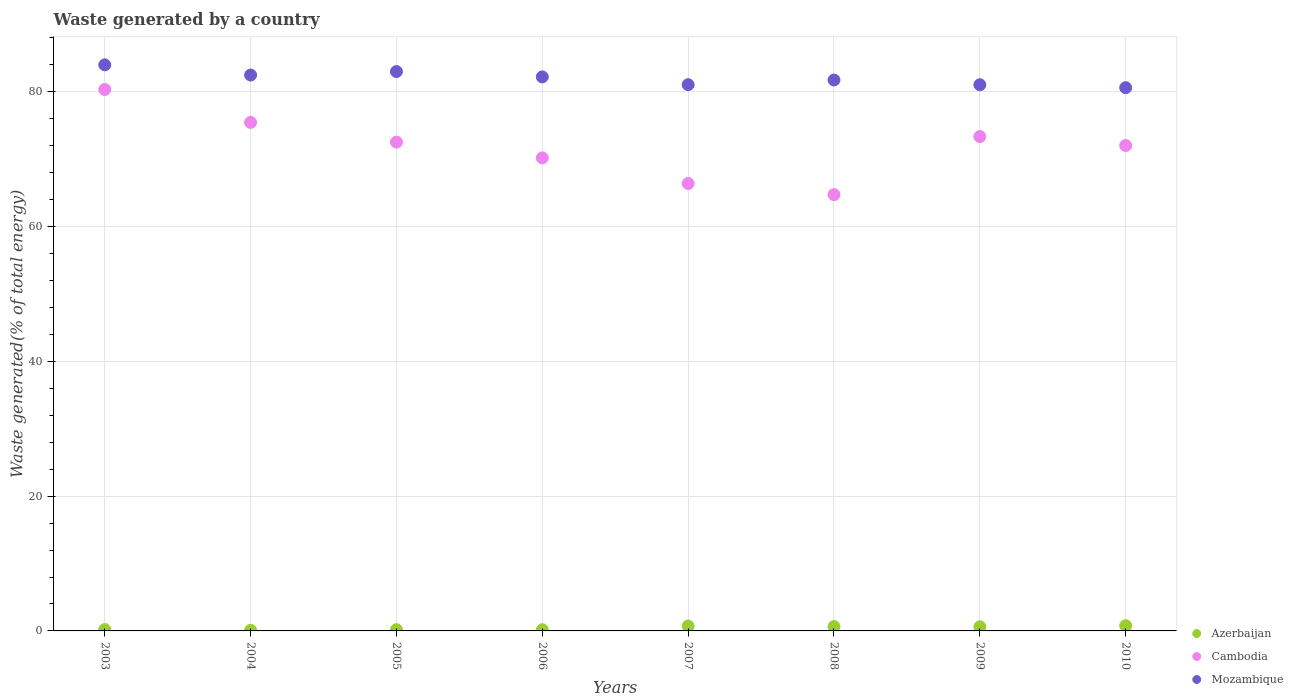How many different coloured dotlines are there?
Keep it short and to the point. 3. What is the total waste generated in Mozambique in 2006?
Your answer should be compact. 82.2. Across all years, what is the maximum total waste generated in Mozambique?
Your answer should be compact. 83.99. Across all years, what is the minimum total waste generated in Mozambique?
Give a very brief answer. 80.6. In which year was the total waste generated in Azerbaijan maximum?
Provide a succinct answer. 2010. In which year was the total waste generated in Mozambique minimum?
Provide a succinct answer. 2010. What is the total total waste generated in Mozambique in the graph?
Your response must be concise. 656.09. What is the difference between the total waste generated in Azerbaijan in 2004 and that in 2006?
Your response must be concise. -0.09. What is the difference between the total waste generated in Mozambique in 2010 and the total waste generated in Cambodia in 2008?
Offer a terse response. 15.87. What is the average total waste generated in Azerbaijan per year?
Offer a terse response. 0.43. In the year 2008, what is the difference between the total waste generated in Cambodia and total waste generated in Azerbaijan?
Ensure brevity in your answer.  64.09. What is the ratio of the total waste generated in Mozambique in 2003 to that in 2005?
Your answer should be very brief. 1.01. Is the total waste generated in Cambodia in 2005 less than that in 2006?
Give a very brief answer. No. What is the difference between the highest and the second highest total waste generated in Cambodia?
Your answer should be very brief. 4.89. What is the difference between the highest and the lowest total waste generated in Mozambique?
Offer a terse response. 3.39. Is it the case that in every year, the sum of the total waste generated in Mozambique and total waste generated in Cambodia  is greater than the total waste generated in Azerbaijan?
Your response must be concise. Yes. Is the total waste generated in Mozambique strictly greater than the total waste generated in Cambodia over the years?
Make the answer very short. Yes. Is the total waste generated in Cambodia strictly less than the total waste generated in Mozambique over the years?
Provide a short and direct response. Yes. How many dotlines are there?
Offer a terse response. 3. Are the values on the major ticks of Y-axis written in scientific E-notation?
Your response must be concise. No. Does the graph contain any zero values?
Your answer should be compact. No. How are the legend labels stacked?
Your answer should be compact. Vertical. What is the title of the graph?
Ensure brevity in your answer.  Waste generated by a country. Does "Canada" appear as one of the legend labels in the graph?
Give a very brief answer. No. What is the label or title of the X-axis?
Provide a short and direct response. Years. What is the label or title of the Y-axis?
Give a very brief answer. Waste generated(% of total energy). What is the Waste generated(% of total energy) in Azerbaijan in 2003?
Ensure brevity in your answer.  0.2. What is the Waste generated(% of total energy) in Cambodia in 2003?
Keep it short and to the point. 80.34. What is the Waste generated(% of total energy) in Mozambique in 2003?
Provide a succinct answer. 83.99. What is the Waste generated(% of total energy) of Azerbaijan in 2004?
Offer a terse response. 0.09. What is the Waste generated(% of total energy) of Cambodia in 2004?
Your answer should be compact. 75.45. What is the Waste generated(% of total energy) of Mozambique in 2004?
Keep it short and to the point. 82.48. What is the Waste generated(% of total energy) in Azerbaijan in 2005?
Provide a short and direct response. 0.19. What is the Waste generated(% of total energy) in Cambodia in 2005?
Offer a very short reply. 72.53. What is the Waste generated(% of total energy) of Mozambique in 2005?
Provide a short and direct response. 83. What is the Waste generated(% of total energy) of Azerbaijan in 2006?
Keep it short and to the point. 0.18. What is the Waste generated(% of total energy) in Cambodia in 2006?
Offer a very short reply. 70.19. What is the Waste generated(% of total energy) of Mozambique in 2006?
Your answer should be compact. 82.2. What is the Waste generated(% of total energy) in Azerbaijan in 2007?
Offer a very short reply. 0.73. What is the Waste generated(% of total energy) in Cambodia in 2007?
Provide a succinct answer. 66.38. What is the Waste generated(% of total energy) in Mozambique in 2007?
Make the answer very short. 81.05. What is the Waste generated(% of total energy) of Azerbaijan in 2008?
Offer a very short reply. 0.64. What is the Waste generated(% of total energy) in Cambodia in 2008?
Provide a short and direct response. 64.73. What is the Waste generated(% of total energy) in Mozambique in 2008?
Make the answer very short. 81.74. What is the Waste generated(% of total energy) of Azerbaijan in 2009?
Keep it short and to the point. 0.61. What is the Waste generated(% of total energy) of Cambodia in 2009?
Offer a terse response. 73.35. What is the Waste generated(% of total energy) of Mozambique in 2009?
Ensure brevity in your answer.  81.03. What is the Waste generated(% of total energy) in Azerbaijan in 2010?
Make the answer very short. 0.78. What is the Waste generated(% of total energy) of Cambodia in 2010?
Provide a short and direct response. 72.03. What is the Waste generated(% of total energy) of Mozambique in 2010?
Your answer should be very brief. 80.6. Across all years, what is the maximum Waste generated(% of total energy) in Azerbaijan?
Keep it short and to the point. 0.78. Across all years, what is the maximum Waste generated(% of total energy) of Cambodia?
Your answer should be very brief. 80.34. Across all years, what is the maximum Waste generated(% of total energy) in Mozambique?
Provide a short and direct response. 83.99. Across all years, what is the minimum Waste generated(% of total energy) of Azerbaijan?
Your response must be concise. 0.09. Across all years, what is the minimum Waste generated(% of total energy) of Cambodia?
Offer a terse response. 64.73. Across all years, what is the minimum Waste generated(% of total energy) of Mozambique?
Keep it short and to the point. 80.6. What is the total Waste generated(% of total energy) of Azerbaijan in the graph?
Provide a succinct answer. 3.42. What is the total Waste generated(% of total energy) of Cambodia in the graph?
Give a very brief answer. 575. What is the total Waste generated(% of total energy) of Mozambique in the graph?
Ensure brevity in your answer.  656.09. What is the difference between the Waste generated(% of total energy) of Azerbaijan in 2003 and that in 2004?
Give a very brief answer. 0.1. What is the difference between the Waste generated(% of total energy) of Cambodia in 2003 and that in 2004?
Provide a succinct answer. 4.89. What is the difference between the Waste generated(% of total energy) of Mozambique in 2003 and that in 2004?
Your answer should be very brief. 1.51. What is the difference between the Waste generated(% of total energy) of Azerbaijan in 2003 and that in 2005?
Your response must be concise. 0.01. What is the difference between the Waste generated(% of total energy) in Cambodia in 2003 and that in 2005?
Offer a terse response. 7.81. What is the difference between the Waste generated(% of total energy) in Azerbaijan in 2003 and that in 2006?
Provide a short and direct response. 0.02. What is the difference between the Waste generated(% of total energy) in Cambodia in 2003 and that in 2006?
Give a very brief answer. 10.15. What is the difference between the Waste generated(% of total energy) in Mozambique in 2003 and that in 2006?
Ensure brevity in your answer.  1.79. What is the difference between the Waste generated(% of total energy) of Azerbaijan in 2003 and that in 2007?
Provide a short and direct response. -0.53. What is the difference between the Waste generated(% of total energy) of Cambodia in 2003 and that in 2007?
Provide a succinct answer. 13.95. What is the difference between the Waste generated(% of total energy) of Mozambique in 2003 and that in 2007?
Offer a terse response. 2.94. What is the difference between the Waste generated(% of total energy) of Azerbaijan in 2003 and that in 2008?
Ensure brevity in your answer.  -0.44. What is the difference between the Waste generated(% of total energy) in Cambodia in 2003 and that in 2008?
Ensure brevity in your answer.  15.61. What is the difference between the Waste generated(% of total energy) in Mozambique in 2003 and that in 2008?
Keep it short and to the point. 2.25. What is the difference between the Waste generated(% of total energy) in Azerbaijan in 2003 and that in 2009?
Make the answer very short. -0.42. What is the difference between the Waste generated(% of total energy) in Cambodia in 2003 and that in 2009?
Your answer should be very brief. 6.99. What is the difference between the Waste generated(% of total energy) of Mozambique in 2003 and that in 2009?
Provide a short and direct response. 2.96. What is the difference between the Waste generated(% of total energy) in Azerbaijan in 2003 and that in 2010?
Offer a very short reply. -0.58. What is the difference between the Waste generated(% of total energy) of Cambodia in 2003 and that in 2010?
Offer a very short reply. 8.31. What is the difference between the Waste generated(% of total energy) of Mozambique in 2003 and that in 2010?
Your response must be concise. 3.39. What is the difference between the Waste generated(% of total energy) in Azerbaijan in 2004 and that in 2005?
Your answer should be very brief. -0.09. What is the difference between the Waste generated(% of total energy) of Cambodia in 2004 and that in 2005?
Provide a succinct answer. 2.93. What is the difference between the Waste generated(% of total energy) in Mozambique in 2004 and that in 2005?
Keep it short and to the point. -0.52. What is the difference between the Waste generated(% of total energy) in Azerbaijan in 2004 and that in 2006?
Offer a very short reply. -0.09. What is the difference between the Waste generated(% of total energy) of Cambodia in 2004 and that in 2006?
Ensure brevity in your answer.  5.26. What is the difference between the Waste generated(% of total energy) in Mozambique in 2004 and that in 2006?
Provide a succinct answer. 0.28. What is the difference between the Waste generated(% of total energy) in Azerbaijan in 2004 and that in 2007?
Give a very brief answer. -0.63. What is the difference between the Waste generated(% of total energy) of Cambodia in 2004 and that in 2007?
Your answer should be compact. 9.07. What is the difference between the Waste generated(% of total energy) in Mozambique in 2004 and that in 2007?
Provide a short and direct response. 1.43. What is the difference between the Waste generated(% of total energy) in Azerbaijan in 2004 and that in 2008?
Provide a short and direct response. -0.55. What is the difference between the Waste generated(% of total energy) of Cambodia in 2004 and that in 2008?
Make the answer very short. 10.72. What is the difference between the Waste generated(% of total energy) of Mozambique in 2004 and that in 2008?
Your answer should be compact. 0.74. What is the difference between the Waste generated(% of total energy) in Azerbaijan in 2004 and that in 2009?
Provide a short and direct response. -0.52. What is the difference between the Waste generated(% of total energy) of Cambodia in 2004 and that in 2009?
Make the answer very short. 2.1. What is the difference between the Waste generated(% of total energy) of Mozambique in 2004 and that in 2009?
Your answer should be very brief. 1.44. What is the difference between the Waste generated(% of total energy) in Azerbaijan in 2004 and that in 2010?
Provide a succinct answer. -0.68. What is the difference between the Waste generated(% of total energy) in Cambodia in 2004 and that in 2010?
Your answer should be compact. 3.42. What is the difference between the Waste generated(% of total energy) in Mozambique in 2004 and that in 2010?
Provide a short and direct response. 1.87. What is the difference between the Waste generated(% of total energy) in Azerbaijan in 2005 and that in 2006?
Your answer should be compact. 0. What is the difference between the Waste generated(% of total energy) of Cambodia in 2005 and that in 2006?
Your answer should be compact. 2.33. What is the difference between the Waste generated(% of total energy) in Mozambique in 2005 and that in 2006?
Provide a short and direct response. 0.8. What is the difference between the Waste generated(% of total energy) of Azerbaijan in 2005 and that in 2007?
Your response must be concise. -0.54. What is the difference between the Waste generated(% of total energy) in Cambodia in 2005 and that in 2007?
Provide a succinct answer. 6.14. What is the difference between the Waste generated(% of total energy) in Mozambique in 2005 and that in 2007?
Give a very brief answer. 1.95. What is the difference between the Waste generated(% of total energy) of Azerbaijan in 2005 and that in 2008?
Offer a terse response. -0.46. What is the difference between the Waste generated(% of total energy) of Cambodia in 2005 and that in 2008?
Your answer should be very brief. 7.79. What is the difference between the Waste generated(% of total energy) of Mozambique in 2005 and that in 2008?
Ensure brevity in your answer.  1.26. What is the difference between the Waste generated(% of total energy) of Azerbaijan in 2005 and that in 2009?
Keep it short and to the point. -0.43. What is the difference between the Waste generated(% of total energy) of Cambodia in 2005 and that in 2009?
Your response must be concise. -0.82. What is the difference between the Waste generated(% of total energy) of Mozambique in 2005 and that in 2009?
Offer a terse response. 1.96. What is the difference between the Waste generated(% of total energy) in Azerbaijan in 2005 and that in 2010?
Ensure brevity in your answer.  -0.59. What is the difference between the Waste generated(% of total energy) in Cambodia in 2005 and that in 2010?
Your response must be concise. 0.5. What is the difference between the Waste generated(% of total energy) in Mozambique in 2005 and that in 2010?
Make the answer very short. 2.39. What is the difference between the Waste generated(% of total energy) in Azerbaijan in 2006 and that in 2007?
Provide a succinct answer. -0.54. What is the difference between the Waste generated(% of total energy) of Cambodia in 2006 and that in 2007?
Provide a succinct answer. 3.81. What is the difference between the Waste generated(% of total energy) of Mozambique in 2006 and that in 2007?
Give a very brief answer. 1.15. What is the difference between the Waste generated(% of total energy) of Azerbaijan in 2006 and that in 2008?
Your answer should be very brief. -0.46. What is the difference between the Waste generated(% of total energy) of Cambodia in 2006 and that in 2008?
Your answer should be compact. 5.46. What is the difference between the Waste generated(% of total energy) of Mozambique in 2006 and that in 2008?
Your answer should be compact. 0.46. What is the difference between the Waste generated(% of total energy) of Azerbaijan in 2006 and that in 2009?
Provide a succinct answer. -0.43. What is the difference between the Waste generated(% of total energy) of Cambodia in 2006 and that in 2009?
Keep it short and to the point. -3.16. What is the difference between the Waste generated(% of total energy) of Mozambique in 2006 and that in 2009?
Provide a succinct answer. 1.17. What is the difference between the Waste generated(% of total energy) of Azerbaijan in 2006 and that in 2010?
Give a very brief answer. -0.6. What is the difference between the Waste generated(% of total energy) of Cambodia in 2006 and that in 2010?
Give a very brief answer. -1.84. What is the difference between the Waste generated(% of total energy) in Mozambique in 2006 and that in 2010?
Ensure brevity in your answer.  1.6. What is the difference between the Waste generated(% of total energy) in Azerbaijan in 2007 and that in 2008?
Give a very brief answer. 0.08. What is the difference between the Waste generated(% of total energy) in Cambodia in 2007 and that in 2008?
Provide a succinct answer. 1.65. What is the difference between the Waste generated(% of total energy) of Mozambique in 2007 and that in 2008?
Your answer should be very brief. -0.69. What is the difference between the Waste generated(% of total energy) of Azerbaijan in 2007 and that in 2009?
Offer a very short reply. 0.11. What is the difference between the Waste generated(% of total energy) of Cambodia in 2007 and that in 2009?
Provide a short and direct response. -6.96. What is the difference between the Waste generated(% of total energy) of Mozambique in 2007 and that in 2009?
Provide a succinct answer. 0.01. What is the difference between the Waste generated(% of total energy) in Azerbaijan in 2007 and that in 2010?
Provide a succinct answer. -0.05. What is the difference between the Waste generated(% of total energy) of Cambodia in 2007 and that in 2010?
Offer a very short reply. -5.64. What is the difference between the Waste generated(% of total energy) in Mozambique in 2007 and that in 2010?
Make the answer very short. 0.44. What is the difference between the Waste generated(% of total energy) in Azerbaijan in 2008 and that in 2009?
Keep it short and to the point. 0.03. What is the difference between the Waste generated(% of total energy) of Cambodia in 2008 and that in 2009?
Your answer should be very brief. -8.62. What is the difference between the Waste generated(% of total energy) in Mozambique in 2008 and that in 2009?
Your response must be concise. 0.71. What is the difference between the Waste generated(% of total energy) of Azerbaijan in 2008 and that in 2010?
Offer a terse response. -0.14. What is the difference between the Waste generated(% of total energy) in Cambodia in 2008 and that in 2010?
Your response must be concise. -7.3. What is the difference between the Waste generated(% of total energy) of Mozambique in 2008 and that in 2010?
Provide a short and direct response. 1.14. What is the difference between the Waste generated(% of total energy) in Azerbaijan in 2009 and that in 2010?
Keep it short and to the point. -0.16. What is the difference between the Waste generated(% of total energy) in Cambodia in 2009 and that in 2010?
Your answer should be compact. 1.32. What is the difference between the Waste generated(% of total energy) of Mozambique in 2009 and that in 2010?
Keep it short and to the point. 0.43. What is the difference between the Waste generated(% of total energy) in Azerbaijan in 2003 and the Waste generated(% of total energy) in Cambodia in 2004?
Your answer should be compact. -75.25. What is the difference between the Waste generated(% of total energy) in Azerbaijan in 2003 and the Waste generated(% of total energy) in Mozambique in 2004?
Keep it short and to the point. -82.28. What is the difference between the Waste generated(% of total energy) in Cambodia in 2003 and the Waste generated(% of total energy) in Mozambique in 2004?
Give a very brief answer. -2.14. What is the difference between the Waste generated(% of total energy) of Azerbaijan in 2003 and the Waste generated(% of total energy) of Cambodia in 2005?
Provide a short and direct response. -72.33. What is the difference between the Waste generated(% of total energy) of Azerbaijan in 2003 and the Waste generated(% of total energy) of Mozambique in 2005?
Keep it short and to the point. -82.8. What is the difference between the Waste generated(% of total energy) in Cambodia in 2003 and the Waste generated(% of total energy) in Mozambique in 2005?
Offer a very short reply. -2.66. What is the difference between the Waste generated(% of total energy) in Azerbaijan in 2003 and the Waste generated(% of total energy) in Cambodia in 2006?
Make the answer very short. -69.99. What is the difference between the Waste generated(% of total energy) of Azerbaijan in 2003 and the Waste generated(% of total energy) of Mozambique in 2006?
Provide a succinct answer. -82. What is the difference between the Waste generated(% of total energy) of Cambodia in 2003 and the Waste generated(% of total energy) of Mozambique in 2006?
Your answer should be compact. -1.86. What is the difference between the Waste generated(% of total energy) in Azerbaijan in 2003 and the Waste generated(% of total energy) in Cambodia in 2007?
Your answer should be very brief. -66.19. What is the difference between the Waste generated(% of total energy) of Azerbaijan in 2003 and the Waste generated(% of total energy) of Mozambique in 2007?
Offer a terse response. -80.85. What is the difference between the Waste generated(% of total energy) in Cambodia in 2003 and the Waste generated(% of total energy) in Mozambique in 2007?
Your answer should be very brief. -0.71. What is the difference between the Waste generated(% of total energy) of Azerbaijan in 2003 and the Waste generated(% of total energy) of Cambodia in 2008?
Your response must be concise. -64.53. What is the difference between the Waste generated(% of total energy) in Azerbaijan in 2003 and the Waste generated(% of total energy) in Mozambique in 2008?
Offer a terse response. -81.54. What is the difference between the Waste generated(% of total energy) in Cambodia in 2003 and the Waste generated(% of total energy) in Mozambique in 2008?
Offer a very short reply. -1.4. What is the difference between the Waste generated(% of total energy) in Azerbaijan in 2003 and the Waste generated(% of total energy) in Cambodia in 2009?
Make the answer very short. -73.15. What is the difference between the Waste generated(% of total energy) in Azerbaijan in 2003 and the Waste generated(% of total energy) in Mozambique in 2009?
Keep it short and to the point. -80.84. What is the difference between the Waste generated(% of total energy) in Cambodia in 2003 and the Waste generated(% of total energy) in Mozambique in 2009?
Provide a succinct answer. -0.7. What is the difference between the Waste generated(% of total energy) of Azerbaijan in 2003 and the Waste generated(% of total energy) of Cambodia in 2010?
Give a very brief answer. -71.83. What is the difference between the Waste generated(% of total energy) of Azerbaijan in 2003 and the Waste generated(% of total energy) of Mozambique in 2010?
Provide a short and direct response. -80.41. What is the difference between the Waste generated(% of total energy) in Cambodia in 2003 and the Waste generated(% of total energy) in Mozambique in 2010?
Give a very brief answer. -0.27. What is the difference between the Waste generated(% of total energy) in Azerbaijan in 2004 and the Waste generated(% of total energy) in Cambodia in 2005?
Offer a terse response. -72.43. What is the difference between the Waste generated(% of total energy) of Azerbaijan in 2004 and the Waste generated(% of total energy) of Mozambique in 2005?
Keep it short and to the point. -82.9. What is the difference between the Waste generated(% of total energy) of Cambodia in 2004 and the Waste generated(% of total energy) of Mozambique in 2005?
Make the answer very short. -7.55. What is the difference between the Waste generated(% of total energy) in Azerbaijan in 2004 and the Waste generated(% of total energy) in Cambodia in 2006?
Your answer should be compact. -70.1. What is the difference between the Waste generated(% of total energy) of Azerbaijan in 2004 and the Waste generated(% of total energy) of Mozambique in 2006?
Your answer should be very brief. -82.11. What is the difference between the Waste generated(% of total energy) of Cambodia in 2004 and the Waste generated(% of total energy) of Mozambique in 2006?
Provide a succinct answer. -6.75. What is the difference between the Waste generated(% of total energy) in Azerbaijan in 2004 and the Waste generated(% of total energy) in Cambodia in 2007?
Give a very brief answer. -66.29. What is the difference between the Waste generated(% of total energy) of Azerbaijan in 2004 and the Waste generated(% of total energy) of Mozambique in 2007?
Provide a succinct answer. -80.95. What is the difference between the Waste generated(% of total energy) of Cambodia in 2004 and the Waste generated(% of total energy) of Mozambique in 2007?
Your answer should be compact. -5.6. What is the difference between the Waste generated(% of total energy) in Azerbaijan in 2004 and the Waste generated(% of total energy) in Cambodia in 2008?
Keep it short and to the point. -64.64. What is the difference between the Waste generated(% of total energy) of Azerbaijan in 2004 and the Waste generated(% of total energy) of Mozambique in 2008?
Your answer should be compact. -81.65. What is the difference between the Waste generated(% of total energy) in Cambodia in 2004 and the Waste generated(% of total energy) in Mozambique in 2008?
Give a very brief answer. -6.29. What is the difference between the Waste generated(% of total energy) of Azerbaijan in 2004 and the Waste generated(% of total energy) of Cambodia in 2009?
Provide a succinct answer. -73.25. What is the difference between the Waste generated(% of total energy) of Azerbaijan in 2004 and the Waste generated(% of total energy) of Mozambique in 2009?
Provide a short and direct response. -80.94. What is the difference between the Waste generated(% of total energy) in Cambodia in 2004 and the Waste generated(% of total energy) in Mozambique in 2009?
Give a very brief answer. -5.58. What is the difference between the Waste generated(% of total energy) in Azerbaijan in 2004 and the Waste generated(% of total energy) in Cambodia in 2010?
Ensure brevity in your answer.  -71.93. What is the difference between the Waste generated(% of total energy) of Azerbaijan in 2004 and the Waste generated(% of total energy) of Mozambique in 2010?
Keep it short and to the point. -80.51. What is the difference between the Waste generated(% of total energy) in Cambodia in 2004 and the Waste generated(% of total energy) in Mozambique in 2010?
Your response must be concise. -5.15. What is the difference between the Waste generated(% of total energy) in Azerbaijan in 2005 and the Waste generated(% of total energy) in Cambodia in 2006?
Offer a terse response. -70. What is the difference between the Waste generated(% of total energy) of Azerbaijan in 2005 and the Waste generated(% of total energy) of Mozambique in 2006?
Make the answer very short. -82.02. What is the difference between the Waste generated(% of total energy) of Cambodia in 2005 and the Waste generated(% of total energy) of Mozambique in 2006?
Your answer should be very brief. -9.68. What is the difference between the Waste generated(% of total energy) of Azerbaijan in 2005 and the Waste generated(% of total energy) of Cambodia in 2007?
Offer a very short reply. -66.2. What is the difference between the Waste generated(% of total energy) in Azerbaijan in 2005 and the Waste generated(% of total energy) in Mozambique in 2007?
Provide a succinct answer. -80.86. What is the difference between the Waste generated(% of total energy) of Cambodia in 2005 and the Waste generated(% of total energy) of Mozambique in 2007?
Ensure brevity in your answer.  -8.52. What is the difference between the Waste generated(% of total energy) in Azerbaijan in 2005 and the Waste generated(% of total energy) in Cambodia in 2008?
Provide a short and direct response. -64.55. What is the difference between the Waste generated(% of total energy) in Azerbaijan in 2005 and the Waste generated(% of total energy) in Mozambique in 2008?
Your answer should be very brief. -81.55. What is the difference between the Waste generated(% of total energy) in Cambodia in 2005 and the Waste generated(% of total energy) in Mozambique in 2008?
Offer a terse response. -9.21. What is the difference between the Waste generated(% of total energy) in Azerbaijan in 2005 and the Waste generated(% of total energy) in Cambodia in 2009?
Offer a terse response. -73.16. What is the difference between the Waste generated(% of total energy) in Azerbaijan in 2005 and the Waste generated(% of total energy) in Mozambique in 2009?
Ensure brevity in your answer.  -80.85. What is the difference between the Waste generated(% of total energy) in Cambodia in 2005 and the Waste generated(% of total energy) in Mozambique in 2009?
Offer a terse response. -8.51. What is the difference between the Waste generated(% of total energy) of Azerbaijan in 2005 and the Waste generated(% of total energy) of Cambodia in 2010?
Give a very brief answer. -71.84. What is the difference between the Waste generated(% of total energy) of Azerbaijan in 2005 and the Waste generated(% of total energy) of Mozambique in 2010?
Offer a very short reply. -80.42. What is the difference between the Waste generated(% of total energy) of Cambodia in 2005 and the Waste generated(% of total energy) of Mozambique in 2010?
Offer a very short reply. -8.08. What is the difference between the Waste generated(% of total energy) in Azerbaijan in 2006 and the Waste generated(% of total energy) in Cambodia in 2007?
Offer a terse response. -66.2. What is the difference between the Waste generated(% of total energy) of Azerbaijan in 2006 and the Waste generated(% of total energy) of Mozambique in 2007?
Give a very brief answer. -80.87. What is the difference between the Waste generated(% of total energy) in Cambodia in 2006 and the Waste generated(% of total energy) in Mozambique in 2007?
Your answer should be compact. -10.86. What is the difference between the Waste generated(% of total energy) in Azerbaijan in 2006 and the Waste generated(% of total energy) in Cambodia in 2008?
Your answer should be compact. -64.55. What is the difference between the Waste generated(% of total energy) of Azerbaijan in 2006 and the Waste generated(% of total energy) of Mozambique in 2008?
Your answer should be very brief. -81.56. What is the difference between the Waste generated(% of total energy) of Cambodia in 2006 and the Waste generated(% of total energy) of Mozambique in 2008?
Provide a succinct answer. -11.55. What is the difference between the Waste generated(% of total energy) in Azerbaijan in 2006 and the Waste generated(% of total energy) in Cambodia in 2009?
Ensure brevity in your answer.  -73.17. What is the difference between the Waste generated(% of total energy) in Azerbaijan in 2006 and the Waste generated(% of total energy) in Mozambique in 2009?
Your response must be concise. -80.85. What is the difference between the Waste generated(% of total energy) in Cambodia in 2006 and the Waste generated(% of total energy) in Mozambique in 2009?
Offer a very short reply. -10.84. What is the difference between the Waste generated(% of total energy) in Azerbaijan in 2006 and the Waste generated(% of total energy) in Cambodia in 2010?
Make the answer very short. -71.85. What is the difference between the Waste generated(% of total energy) of Azerbaijan in 2006 and the Waste generated(% of total energy) of Mozambique in 2010?
Offer a terse response. -80.42. What is the difference between the Waste generated(% of total energy) in Cambodia in 2006 and the Waste generated(% of total energy) in Mozambique in 2010?
Your response must be concise. -10.41. What is the difference between the Waste generated(% of total energy) of Azerbaijan in 2007 and the Waste generated(% of total energy) of Cambodia in 2008?
Provide a succinct answer. -64.01. What is the difference between the Waste generated(% of total energy) of Azerbaijan in 2007 and the Waste generated(% of total energy) of Mozambique in 2008?
Make the answer very short. -81.01. What is the difference between the Waste generated(% of total energy) in Cambodia in 2007 and the Waste generated(% of total energy) in Mozambique in 2008?
Offer a terse response. -15.36. What is the difference between the Waste generated(% of total energy) in Azerbaijan in 2007 and the Waste generated(% of total energy) in Cambodia in 2009?
Ensure brevity in your answer.  -72.62. What is the difference between the Waste generated(% of total energy) in Azerbaijan in 2007 and the Waste generated(% of total energy) in Mozambique in 2009?
Offer a very short reply. -80.31. What is the difference between the Waste generated(% of total energy) in Cambodia in 2007 and the Waste generated(% of total energy) in Mozambique in 2009?
Offer a very short reply. -14.65. What is the difference between the Waste generated(% of total energy) of Azerbaijan in 2007 and the Waste generated(% of total energy) of Cambodia in 2010?
Your response must be concise. -71.3. What is the difference between the Waste generated(% of total energy) in Azerbaijan in 2007 and the Waste generated(% of total energy) in Mozambique in 2010?
Give a very brief answer. -79.88. What is the difference between the Waste generated(% of total energy) of Cambodia in 2007 and the Waste generated(% of total energy) of Mozambique in 2010?
Offer a terse response. -14.22. What is the difference between the Waste generated(% of total energy) in Azerbaijan in 2008 and the Waste generated(% of total energy) in Cambodia in 2009?
Keep it short and to the point. -72.71. What is the difference between the Waste generated(% of total energy) of Azerbaijan in 2008 and the Waste generated(% of total energy) of Mozambique in 2009?
Your answer should be compact. -80.39. What is the difference between the Waste generated(% of total energy) of Cambodia in 2008 and the Waste generated(% of total energy) of Mozambique in 2009?
Provide a succinct answer. -16.3. What is the difference between the Waste generated(% of total energy) in Azerbaijan in 2008 and the Waste generated(% of total energy) in Cambodia in 2010?
Ensure brevity in your answer.  -71.39. What is the difference between the Waste generated(% of total energy) of Azerbaijan in 2008 and the Waste generated(% of total energy) of Mozambique in 2010?
Your answer should be compact. -79.96. What is the difference between the Waste generated(% of total energy) in Cambodia in 2008 and the Waste generated(% of total energy) in Mozambique in 2010?
Your response must be concise. -15.87. What is the difference between the Waste generated(% of total energy) in Azerbaijan in 2009 and the Waste generated(% of total energy) in Cambodia in 2010?
Ensure brevity in your answer.  -71.41. What is the difference between the Waste generated(% of total energy) in Azerbaijan in 2009 and the Waste generated(% of total energy) in Mozambique in 2010?
Provide a succinct answer. -79.99. What is the difference between the Waste generated(% of total energy) of Cambodia in 2009 and the Waste generated(% of total energy) of Mozambique in 2010?
Make the answer very short. -7.26. What is the average Waste generated(% of total energy) of Azerbaijan per year?
Offer a very short reply. 0.43. What is the average Waste generated(% of total energy) in Cambodia per year?
Keep it short and to the point. 71.87. What is the average Waste generated(% of total energy) of Mozambique per year?
Provide a short and direct response. 82.01. In the year 2003, what is the difference between the Waste generated(% of total energy) of Azerbaijan and Waste generated(% of total energy) of Cambodia?
Your answer should be very brief. -80.14. In the year 2003, what is the difference between the Waste generated(% of total energy) of Azerbaijan and Waste generated(% of total energy) of Mozambique?
Your response must be concise. -83.79. In the year 2003, what is the difference between the Waste generated(% of total energy) of Cambodia and Waste generated(% of total energy) of Mozambique?
Your answer should be compact. -3.65. In the year 2004, what is the difference between the Waste generated(% of total energy) in Azerbaijan and Waste generated(% of total energy) in Cambodia?
Give a very brief answer. -75.36. In the year 2004, what is the difference between the Waste generated(% of total energy) in Azerbaijan and Waste generated(% of total energy) in Mozambique?
Ensure brevity in your answer.  -82.38. In the year 2004, what is the difference between the Waste generated(% of total energy) in Cambodia and Waste generated(% of total energy) in Mozambique?
Make the answer very short. -7.03. In the year 2005, what is the difference between the Waste generated(% of total energy) of Azerbaijan and Waste generated(% of total energy) of Cambodia?
Give a very brief answer. -72.34. In the year 2005, what is the difference between the Waste generated(% of total energy) of Azerbaijan and Waste generated(% of total energy) of Mozambique?
Your answer should be compact. -82.81. In the year 2005, what is the difference between the Waste generated(% of total energy) in Cambodia and Waste generated(% of total energy) in Mozambique?
Your response must be concise. -10.47. In the year 2006, what is the difference between the Waste generated(% of total energy) in Azerbaijan and Waste generated(% of total energy) in Cambodia?
Provide a succinct answer. -70.01. In the year 2006, what is the difference between the Waste generated(% of total energy) of Azerbaijan and Waste generated(% of total energy) of Mozambique?
Provide a succinct answer. -82.02. In the year 2006, what is the difference between the Waste generated(% of total energy) of Cambodia and Waste generated(% of total energy) of Mozambique?
Your answer should be very brief. -12.01. In the year 2007, what is the difference between the Waste generated(% of total energy) in Azerbaijan and Waste generated(% of total energy) in Cambodia?
Offer a terse response. -65.66. In the year 2007, what is the difference between the Waste generated(% of total energy) in Azerbaijan and Waste generated(% of total energy) in Mozambique?
Your response must be concise. -80.32. In the year 2007, what is the difference between the Waste generated(% of total energy) in Cambodia and Waste generated(% of total energy) in Mozambique?
Provide a succinct answer. -14.66. In the year 2008, what is the difference between the Waste generated(% of total energy) of Azerbaijan and Waste generated(% of total energy) of Cambodia?
Your answer should be compact. -64.09. In the year 2008, what is the difference between the Waste generated(% of total energy) in Azerbaijan and Waste generated(% of total energy) in Mozambique?
Your response must be concise. -81.1. In the year 2008, what is the difference between the Waste generated(% of total energy) in Cambodia and Waste generated(% of total energy) in Mozambique?
Ensure brevity in your answer.  -17.01. In the year 2009, what is the difference between the Waste generated(% of total energy) in Azerbaijan and Waste generated(% of total energy) in Cambodia?
Your answer should be very brief. -72.73. In the year 2009, what is the difference between the Waste generated(% of total energy) of Azerbaijan and Waste generated(% of total energy) of Mozambique?
Provide a short and direct response. -80.42. In the year 2009, what is the difference between the Waste generated(% of total energy) of Cambodia and Waste generated(% of total energy) of Mozambique?
Your response must be concise. -7.69. In the year 2010, what is the difference between the Waste generated(% of total energy) in Azerbaijan and Waste generated(% of total energy) in Cambodia?
Offer a terse response. -71.25. In the year 2010, what is the difference between the Waste generated(% of total energy) in Azerbaijan and Waste generated(% of total energy) in Mozambique?
Offer a terse response. -79.83. In the year 2010, what is the difference between the Waste generated(% of total energy) in Cambodia and Waste generated(% of total energy) in Mozambique?
Give a very brief answer. -8.58. What is the ratio of the Waste generated(% of total energy) of Azerbaijan in 2003 to that in 2004?
Your response must be concise. 2.11. What is the ratio of the Waste generated(% of total energy) of Cambodia in 2003 to that in 2004?
Offer a terse response. 1.06. What is the ratio of the Waste generated(% of total energy) in Mozambique in 2003 to that in 2004?
Your answer should be very brief. 1.02. What is the ratio of the Waste generated(% of total energy) of Azerbaijan in 2003 to that in 2005?
Your answer should be compact. 1.06. What is the ratio of the Waste generated(% of total energy) of Cambodia in 2003 to that in 2005?
Keep it short and to the point. 1.11. What is the ratio of the Waste generated(% of total energy) in Mozambique in 2003 to that in 2005?
Keep it short and to the point. 1.01. What is the ratio of the Waste generated(% of total energy) of Azerbaijan in 2003 to that in 2006?
Provide a succinct answer. 1.09. What is the ratio of the Waste generated(% of total energy) of Cambodia in 2003 to that in 2006?
Offer a terse response. 1.14. What is the ratio of the Waste generated(% of total energy) in Mozambique in 2003 to that in 2006?
Ensure brevity in your answer.  1.02. What is the ratio of the Waste generated(% of total energy) in Azerbaijan in 2003 to that in 2007?
Provide a succinct answer. 0.27. What is the ratio of the Waste generated(% of total energy) of Cambodia in 2003 to that in 2007?
Your response must be concise. 1.21. What is the ratio of the Waste generated(% of total energy) of Mozambique in 2003 to that in 2007?
Make the answer very short. 1.04. What is the ratio of the Waste generated(% of total energy) of Azerbaijan in 2003 to that in 2008?
Your response must be concise. 0.31. What is the ratio of the Waste generated(% of total energy) of Cambodia in 2003 to that in 2008?
Your answer should be very brief. 1.24. What is the ratio of the Waste generated(% of total energy) in Mozambique in 2003 to that in 2008?
Make the answer very short. 1.03. What is the ratio of the Waste generated(% of total energy) of Azerbaijan in 2003 to that in 2009?
Ensure brevity in your answer.  0.32. What is the ratio of the Waste generated(% of total energy) of Cambodia in 2003 to that in 2009?
Ensure brevity in your answer.  1.1. What is the ratio of the Waste generated(% of total energy) in Mozambique in 2003 to that in 2009?
Keep it short and to the point. 1.04. What is the ratio of the Waste generated(% of total energy) of Azerbaijan in 2003 to that in 2010?
Give a very brief answer. 0.25. What is the ratio of the Waste generated(% of total energy) of Cambodia in 2003 to that in 2010?
Your answer should be compact. 1.12. What is the ratio of the Waste generated(% of total energy) of Mozambique in 2003 to that in 2010?
Your response must be concise. 1.04. What is the ratio of the Waste generated(% of total energy) in Azerbaijan in 2004 to that in 2005?
Provide a short and direct response. 0.5. What is the ratio of the Waste generated(% of total energy) in Cambodia in 2004 to that in 2005?
Provide a succinct answer. 1.04. What is the ratio of the Waste generated(% of total energy) in Mozambique in 2004 to that in 2005?
Your answer should be compact. 0.99. What is the ratio of the Waste generated(% of total energy) of Azerbaijan in 2004 to that in 2006?
Provide a succinct answer. 0.52. What is the ratio of the Waste generated(% of total energy) of Cambodia in 2004 to that in 2006?
Your answer should be compact. 1.07. What is the ratio of the Waste generated(% of total energy) of Mozambique in 2004 to that in 2006?
Make the answer very short. 1. What is the ratio of the Waste generated(% of total energy) of Azerbaijan in 2004 to that in 2007?
Make the answer very short. 0.13. What is the ratio of the Waste generated(% of total energy) of Cambodia in 2004 to that in 2007?
Provide a short and direct response. 1.14. What is the ratio of the Waste generated(% of total energy) of Mozambique in 2004 to that in 2007?
Give a very brief answer. 1.02. What is the ratio of the Waste generated(% of total energy) of Azerbaijan in 2004 to that in 2008?
Keep it short and to the point. 0.15. What is the ratio of the Waste generated(% of total energy) of Cambodia in 2004 to that in 2008?
Provide a short and direct response. 1.17. What is the ratio of the Waste generated(% of total energy) in Mozambique in 2004 to that in 2008?
Offer a very short reply. 1.01. What is the ratio of the Waste generated(% of total energy) of Azerbaijan in 2004 to that in 2009?
Provide a short and direct response. 0.15. What is the ratio of the Waste generated(% of total energy) of Cambodia in 2004 to that in 2009?
Provide a succinct answer. 1.03. What is the ratio of the Waste generated(% of total energy) of Mozambique in 2004 to that in 2009?
Your answer should be compact. 1.02. What is the ratio of the Waste generated(% of total energy) of Azerbaijan in 2004 to that in 2010?
Your answer should be compact. 0.12. What is the ratio of the Waste generated(% of total energy) of Cambodia in 2004 to that in 2010?
Provide a short and direct response. 1.05. What is the ratio of the Waste generated(% of total energy) of Mozambique in 2004 to that in 2010?
Offer a terse response. 1.02. What is the ratio of the Waste generated(% of total energy) of Azerbaijan in 2005 to that in 2006?
Your response must be concise. 1.03. What is the ratio of the Waste generated(% of total energy) of Cambodia in 2005 to that in 2006?
Your answer should be compact. 1.03. What is the ratio of the Waste generated(% of total energy) in Mozambique in 2005 to that in 2006?
Give a very brief answer. 1.01. What is the ratio of the Waste generated(% of total energy) in Azerbaijan in 2005 to that in 2007?
Your answer should be very brief. 0.26. What is the ratio of the Waste generated(% of total energy) of Cambodia in 2005 to that in 2007?
Ensure brevity in your answer.  1.09. What is the ratio of the Waste generated(% of total energy) of Azerbaijan in 2005 to that in 2008?
Offer a very short reply. 0.29. What is the ratio of the Waste generated(% of total energy) in Cambodia in 2005 to that in 2008?
Ensure brevity in your answer.  1.12. What is the ratio of the Waste generated(% of total energy) of Mozambique in 2005 to that in 2008?
Offer a very short reply. 1.02. What is the ratio of the Waste generated(% of total energy) of Azerbaijan in 2005 to that in 2009?
Your answer should be very brief. 0.3. What is the ratio of the Waste generated(% of total energy) in Cambodia in 2005 to that in 2009?
Provide a succinct answer. 0.99. What is the ratio of the Waste generated(% of total energy) of Mozambique in 2005 to that in 2009?
Provide a succinct answer. 1.02. What is the ratio of the Waste generated(% of total energy) of Azerbaijan in 2005 to that in 2010?
Give a very brief answer. 0.24. What is the ratio of the Waste generated(% of total energy) in Cambodia in 2005 to that in 2010?
Make the answer very short. 1.01. What is the ratio of the Waste generated(% of total energy) of Mozambique in 2005 to that in 2010?
Your response must be concise. 1.03. What is the ratio of the Waste generated(% of total energy) in Azerbaijan in 2006 to that in 2007?
Provide a short and direct response. 0.25. What is the ratio of the Waste generated(% of total energy) of Cambodia in 2006 to that in 2007?
Offer a terse response. 1.06. What is the ratio of the Waste generated(% of total energy) in Mozambique in 2006 to that in 2007?
Keep it short and to the point. 1.01. What is the ratio of the Waste generated(% of total energy) of Azerbaijan in 2006 to that in 2008?
Your answer should be compact. 0.28. What is the ratio of the Waste generated(% of total energy) in Cambodia in 2006 to that in 2008?
Give a very brief answer. 1.08. What is the ratio of the Waste generated(% of total energy) of Mozambique in 2006 to that in 2008?
Provide a short and direct response. 1.01. What is the ratio of the Waste generated(% of total energy) of Azerbaijan in 2006 to that in 2009?
Provide a succinct answer. 0.3. What is the ratio of the Waste generated(% of total energy) in Cambodia in 2006 to that in 2009?
Your response must be concise. 0.96. What is the ratio of the Waste generated(% of total energy) in Mozambique in 2006 to that in 2009?
Provide a short and direct response. 1.01. What is the ratio of the Waste generated(% of total energy) in Azerbaijan in 2006 to that in 2010?
Your answer should be very brief. 0.23. What is the ratio of the Waste generated(% of total energy) in Cambodia in 2006 to that in 2010?
Provide a short and direct response. 0.97. What is the ratio of the Waste generated(% of total energy) in Mozambique in 2006 to that in 2010?
Your answer should be very brief. 1.02. What is the ratio of the Waste generated(% of total energy) in Azerbaijan in 2007 to that in 2008?
Offer a terse response. 1.13. What is the ratio of the Waste generated(% of total energy) of Cambodia in 2007 to that in 2008?
Provide a short and direct response. 1.03. What is the ratio of the Waste generated(% of total energy) of Mozambique in 2007 to that in 2008?
Provide a succinct answer. 0.99. What is the ratio of the Waste generated(% of total energy) of Azerbaijan in 2007 to that in 2009?
Offer a terse response. 1.18. What is the ratio of the Waste generated(% of total energy) of Cambodia in 2007 to that in 2009?
Provide a succinct answer. 0.91. What is the ratio of the Waste generated(% of total energy) of Azerbaijan in 2007 to that in 2010?
Your answer should be compact. 0.93. What is the ratio of the Waste generated(% of total energy) of Cambodia in 2007 to that in 2010?
Your answer should be compact. 0.92. What is the ratio of the Waste generated(% of total energy) of Mozambique in 2007 to that in 2010?
Give a very brief answer. 1.01. What is the ratio of the Waste generated(% of total energy) in Azerbaijan in 2008 to that in 2009?
Give a very brief answer. 1.05. What is the ratio of the Waste generated(% of total energy) in Cambodia in 2008 to that in 2009?
Your answer should be very brief. 0.88. What is the ratio of the Waste generated(% of total energy) in Mozambique in 2008 to that in 2009?
Your response must be concise. 1.01. What is the ratio of the Waste generated(% of total energy) of Azerbaijan in 2008 to that in 2010?
Offer a terse response. 0.83. What is the ratio of the Waste generated(% of total energy) of Cambodia in 2008 to that in 2010?
Provide a short and direct response. 0.9. What is the ratio of the Waste generated(% of total energy) in Mozambique in 2008 to that in 2010?
Offer a very short reply. 1.01. What is the ratio of the Waste generated(% of total energy) in Azerbaijan in 2009 to that in 2010?
Your answer should be very brief. 0.79. What is the ratio of the Waste generated(% of total energy) of Cambodia in 2009 to that in 2010?
Your answer should be very brief. 1.02. What is the difference between the highest and the second highest Waste generated(% of total energy) in Azerbaijan?
Your answer should be compact. 0.05. What is the difference between the highest and the second highest Waste generated(% of total energy) of Cambodia?
Provide a short and direct response. 4.89. What is the difference between the highest and the second highest Waste generated(% of total energy) of Mozambique?
Your answer should be compact. 0.99. What is the difference between the highest and the lowest Waste generated(% of total energy) of Azerbaijan?
Offer a very short reply. 0.68. What is the difference between the highest and the lowest Waste generated(% of total energy) in Cambodia?
Your response must be concise. 15.61. What is the difference between the highest and the lowest Waste generated(% of total energy) of Mozambique?
Make the answer very short. 3.39. 